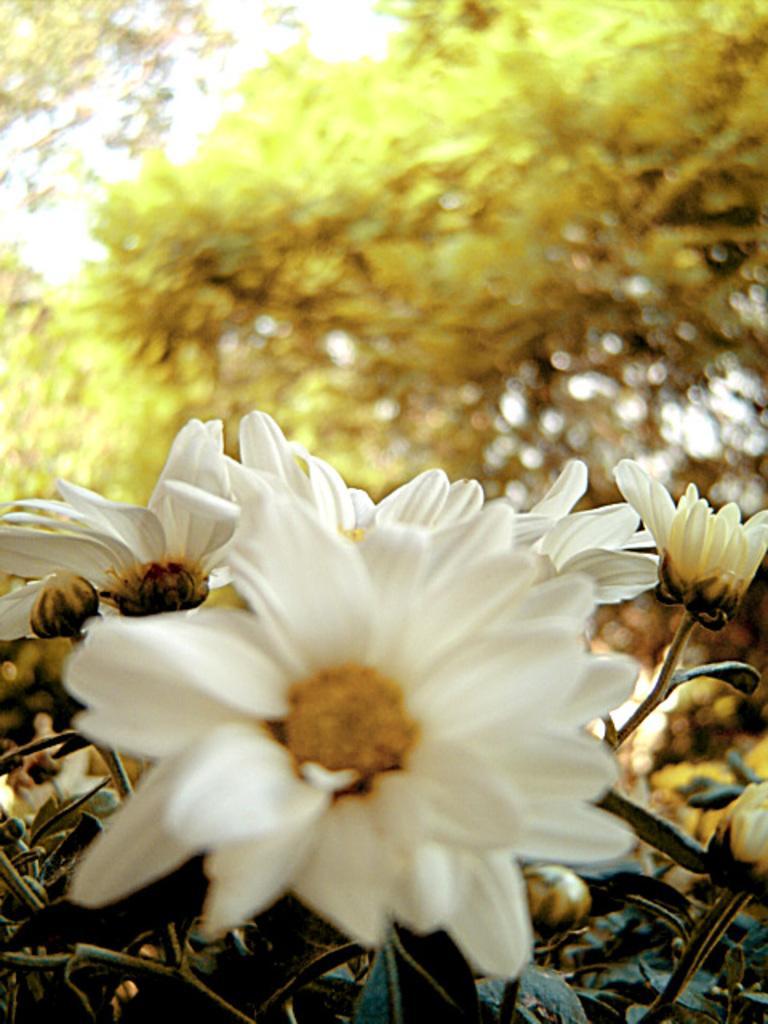Could you give a brief overview of what you see in this image? In this image there are few flowers, plants and trees. 